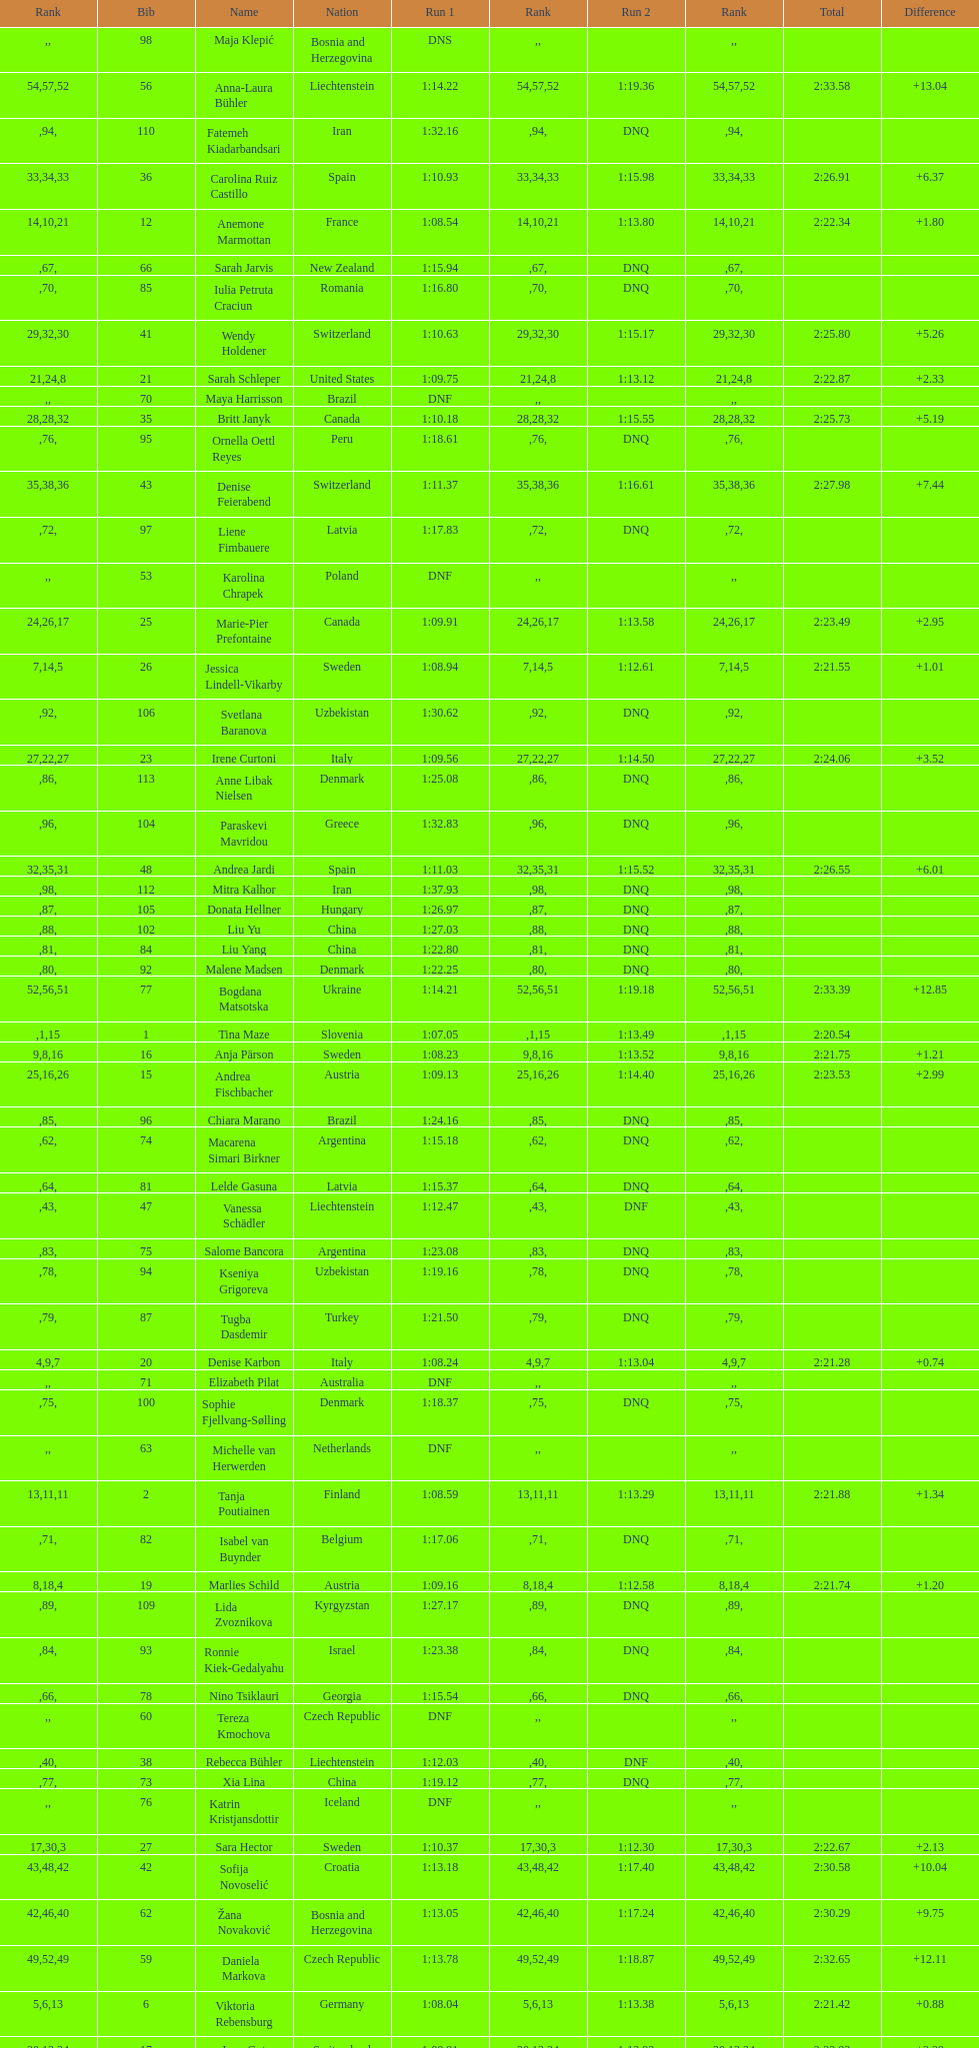How many athletes had the same rank for both run 1 and run 2? 1. 